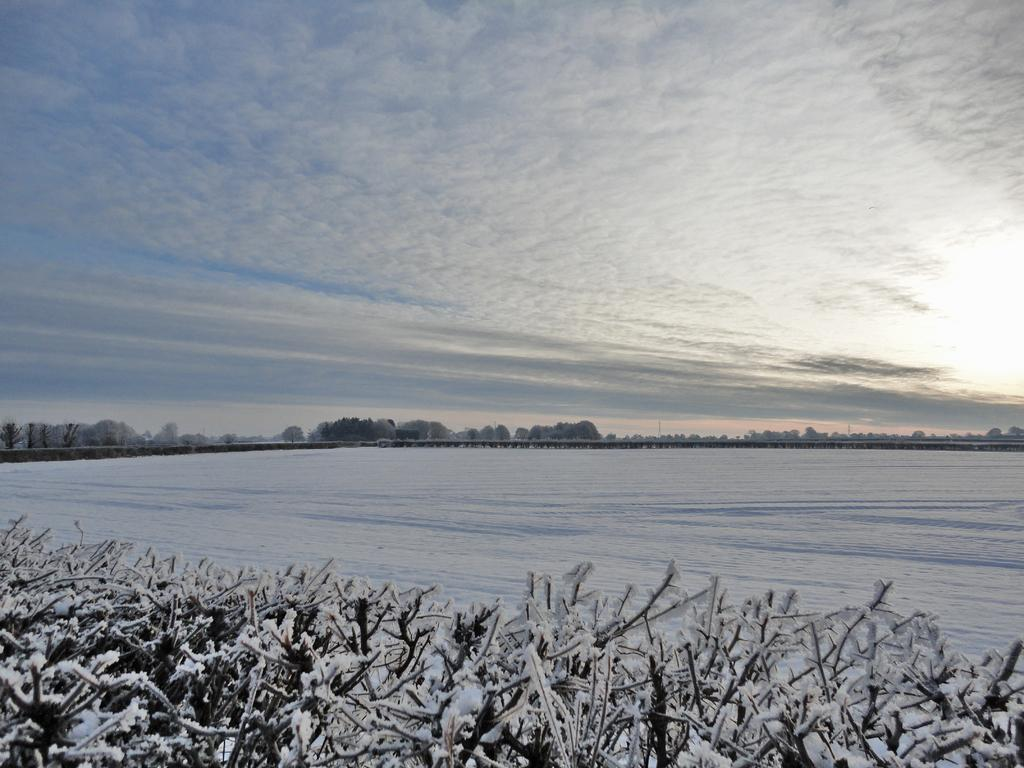What is the condition of the plants in the image? The plants in the image are covered with snow. What body of water is visible in the image? There is a lake in the image. What type of vegetation can be seen in the background of the image? There are trees in the background of the image. How would you describe the quality of the background in the image? The background of the image is slightly blurred. What is the weather like in the image? The sky is cloudy in the image. What route does the cub take to avoid the snow in the image? There is no cub present in the image, so there is no route to discuss. 